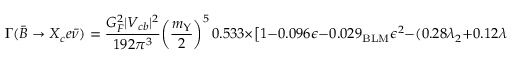Convert formula to latex. <formula><loc_0><loc_0><loc_500><loc_500>\Gamma ( \bar { B } \to X _ { c } e \bar { \nu } ) = { \frac { G _ { F } ^ { 2 } | V _ { c b } | ^ { 2 } } { 1 9 2 \pi ^ { 3 } } } \left ( { \frac { m _ { \Upsilon } } { 2 } } \right ) ^ { 5 } \, 0 . 5 3 3 \times \left [ 1 - 0 . 0 9 6 \epsilon - 0 . 0 2 9 _ { B L M } \epsilon ^ { 2 } - ( 0 . 2 8 \lambda _ { 2 } + 0 . 1 2 \lambda _ { 1 } ) / G e V ^ { 2 } \right ] \, ,</formula> 